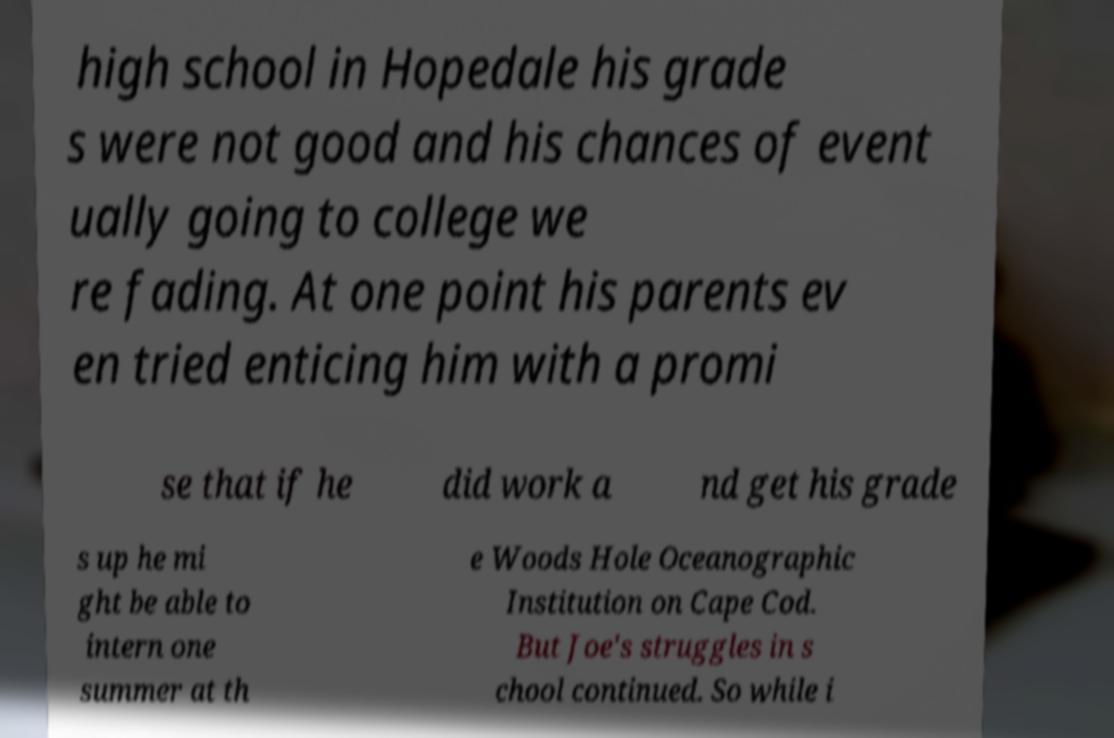For documentation purposes, I need the text within this image transcribed. Could you provide that? high school in Hopedale his grade s were not good and his chances of event ually going to college we re fading. At one point his parents ev en tried enticing him with a promi se that if he did work a nd get his grade s up he mi ght be able to intern one summer at th e Woods Hole Oceanographic Institution on Cape Cod. But Joe's struggles in s chool continued. So while i 